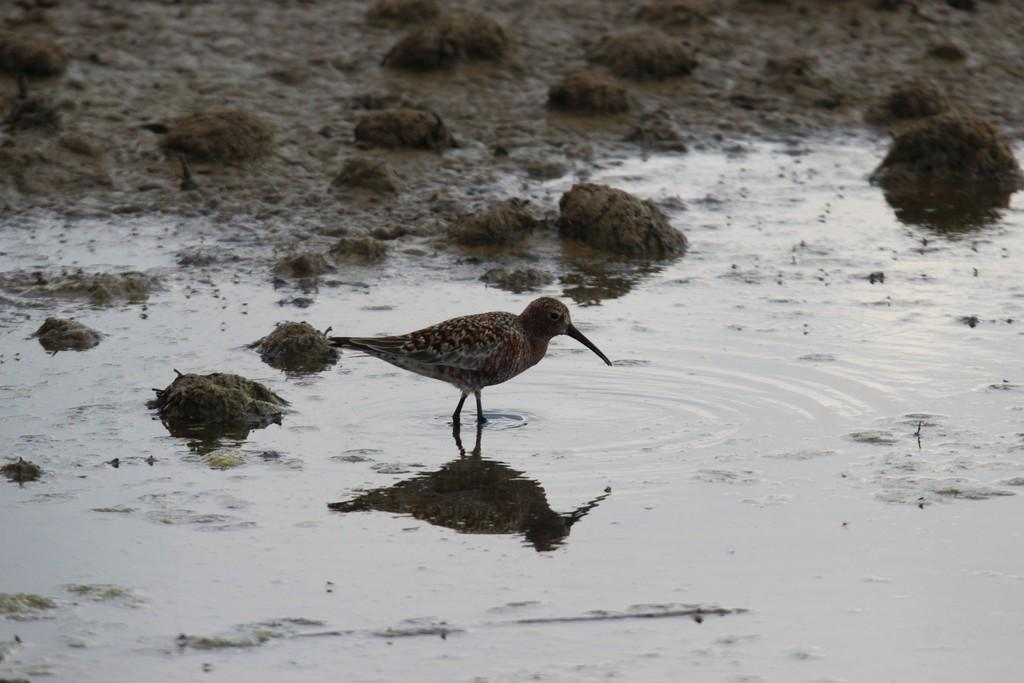What is the main subject in the center of the image? There is a bird in the center of the image. What can be seen at the bottom of the image? There is water visible at the bottom of the image. What type of terrain is visible in the background of the image? There is mud in the background of the image. What type of feather is being used to write on the street in the image? There is no feather or writing on the street present in the image. How is the wax being used in the image? There is no wax present in the image. 